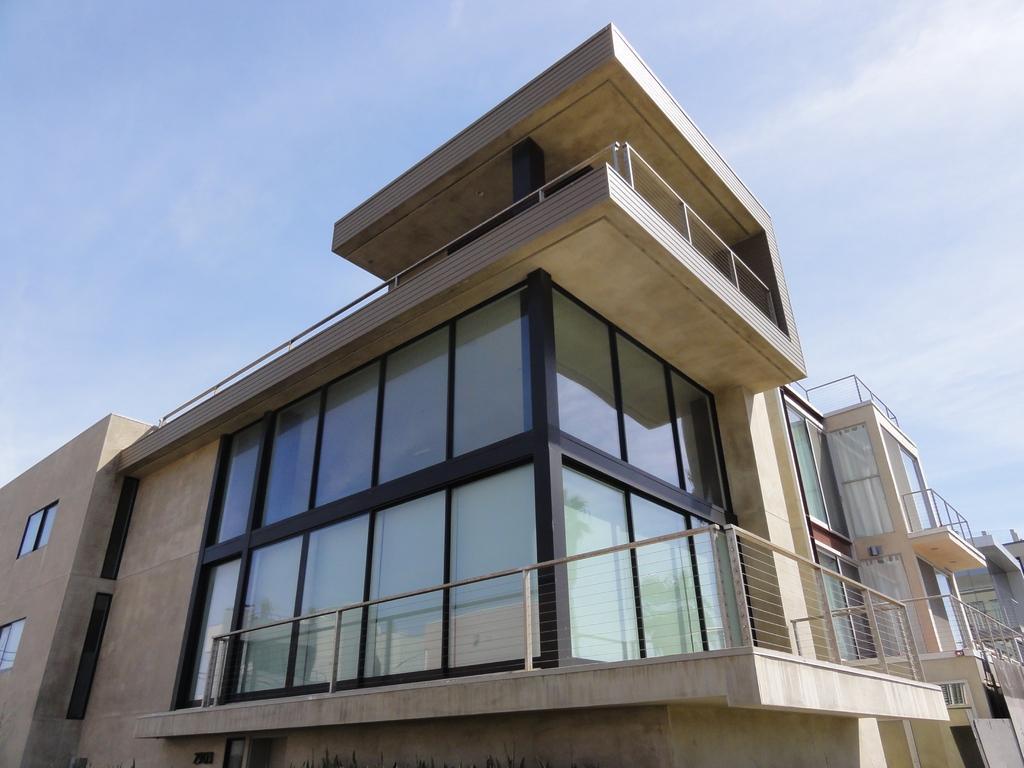Can you describe this image briefly? In the foreground of this image, there is a building, glass doors and the windows. In the background, there is another building on the right. On the top, there is the sky and the cloud. 